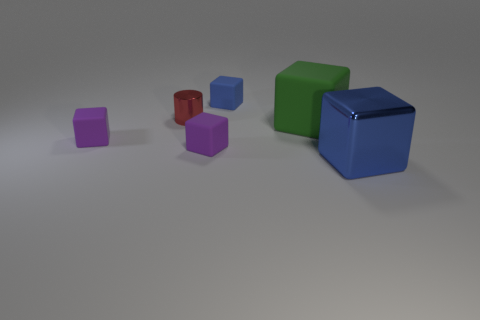Subtract all blue shiny cubes. How many cubes are left? 4 Add 4 large blue objects. How many objects exist? 10 Subtract all green cubes. How many cubes are left? 4 Subtract all cylinders. How many objects are left? 5 Subtract all blue cylinders. Subtract all cyan blocks. How many cylinders are left? 1 Subtract all red blocks. How many yellow cylinders are left? 0 Subtract all purple cubes. Subtract all rubber objects. How many objects are left? 0 Add 2 tiny purple rubber objects. How many tiny purple rubber objects are left? 4 Add 5 big metallic cubes. How many big metallic cubes exist? 6 Subtract 1 red cylinders. How many objects are left? 5 